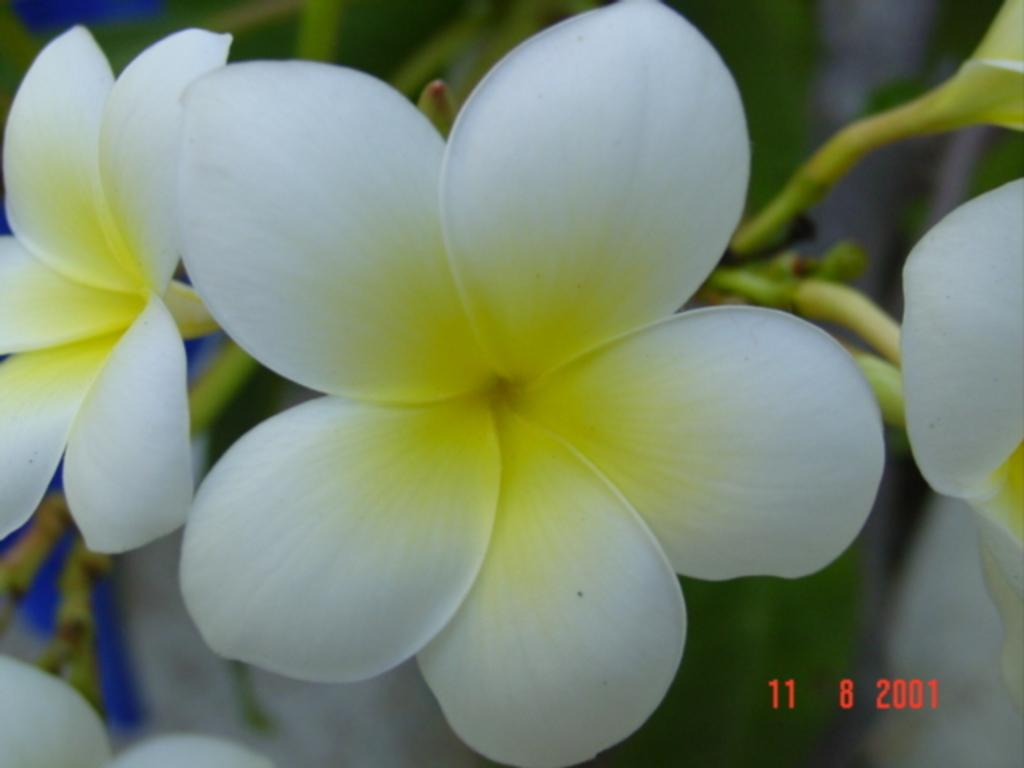What type of living organism is present in the image? There is a plant in the image. What specific features can be observed on the plant? The plant has flowers and buds. Is there any text associated with the image? Yes, there is text at the bottom of the image. What type of popcorn can be seen in the image? There is no popcorn present in the image; it features a plant with flowers and buds. What is the taste of the nation depicted in the image? There is no nation depicted in the image, and therefore no taste can be associated with it. 